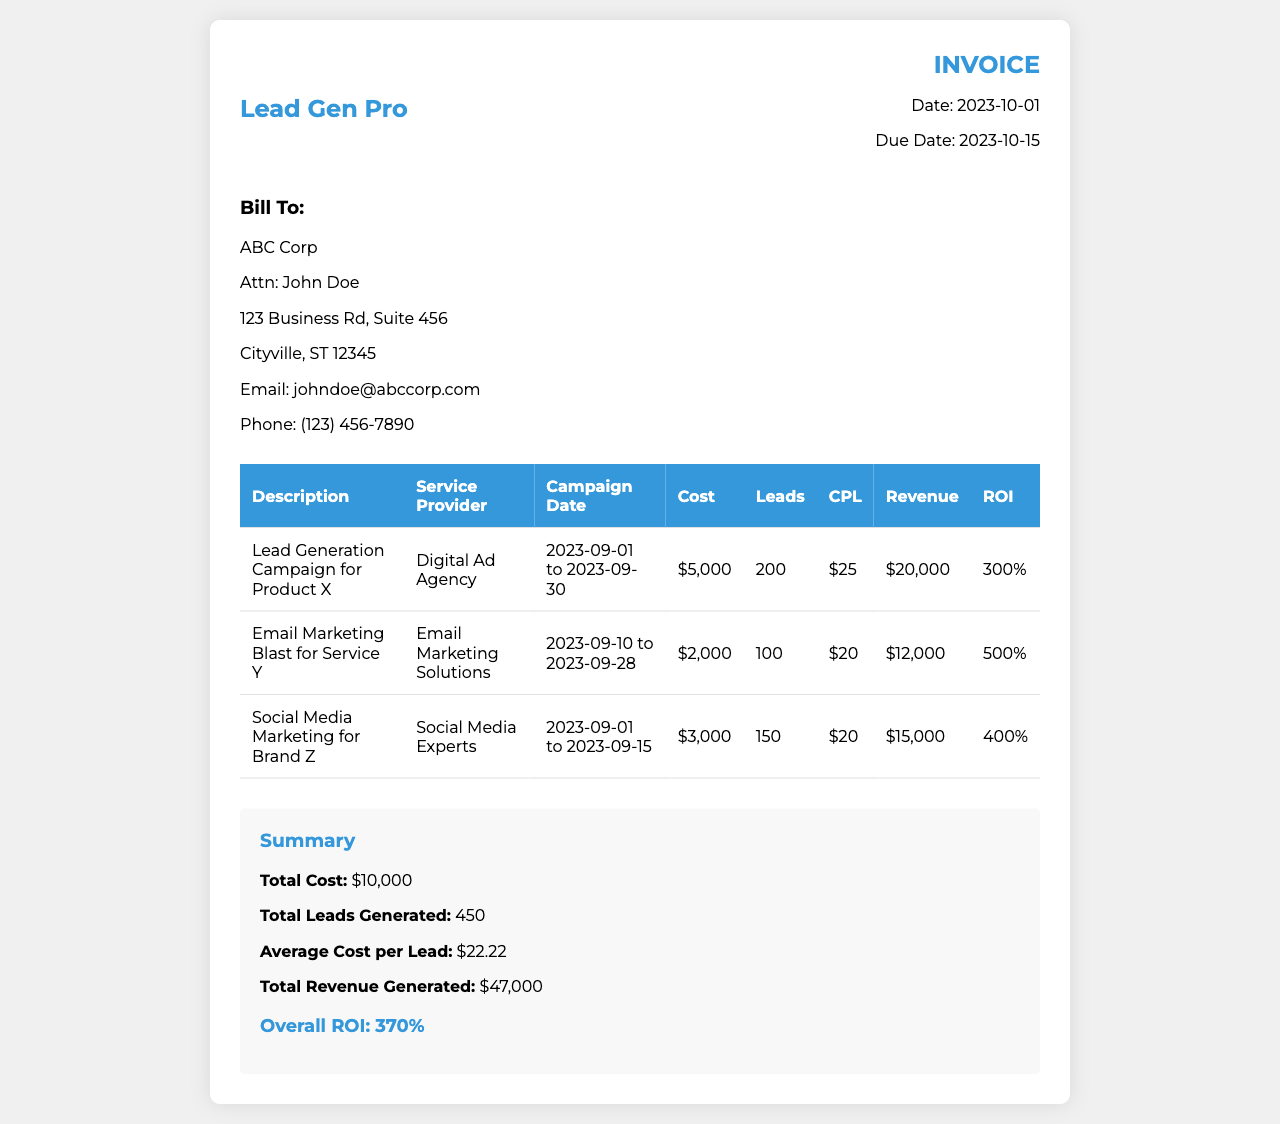What is the total cost? The total cost is clearly indicated in the summary section of the invoice.
Answer: $10,000 Who is the service provider for the Lead Generation Campaign for Product X? The service provider's name is listed in the table under the relevant campaign description.
Answer: Digital Ad Agency How many leads were generated from the Email Marketing Blast for Service Y? The number of leads generated is specified in the table for each campaign.
Answer: 100 What is the ROI for the Social Media Marketing for Brand Z? The ROI is provided in the table for that specific campaign.
Answer: 400% What is the campaign date range for the Lead Generation Campaign for Product X? The campaign date range is presented in the table for that specific campaign.
Answer: 2023-09-01 to 2023-09-30 What is the average cost per lead? The average cost per lead is calculated in the summary section and is based on total cost and total leads.
Answer: $22.22 What is the total revenue generated from all campaigns? The total revenue is summarized at the end of all campaigns in the invoice.
Answer: $47,000 What email address is provided for the billing contact? The email address of the billing contact is specified in the client details.
Answer: johndoe@abccorp.com What is the due date for this invoice? The due date is mentioned in the invoice details at the top of the document.
Answer: 2023-10-15 